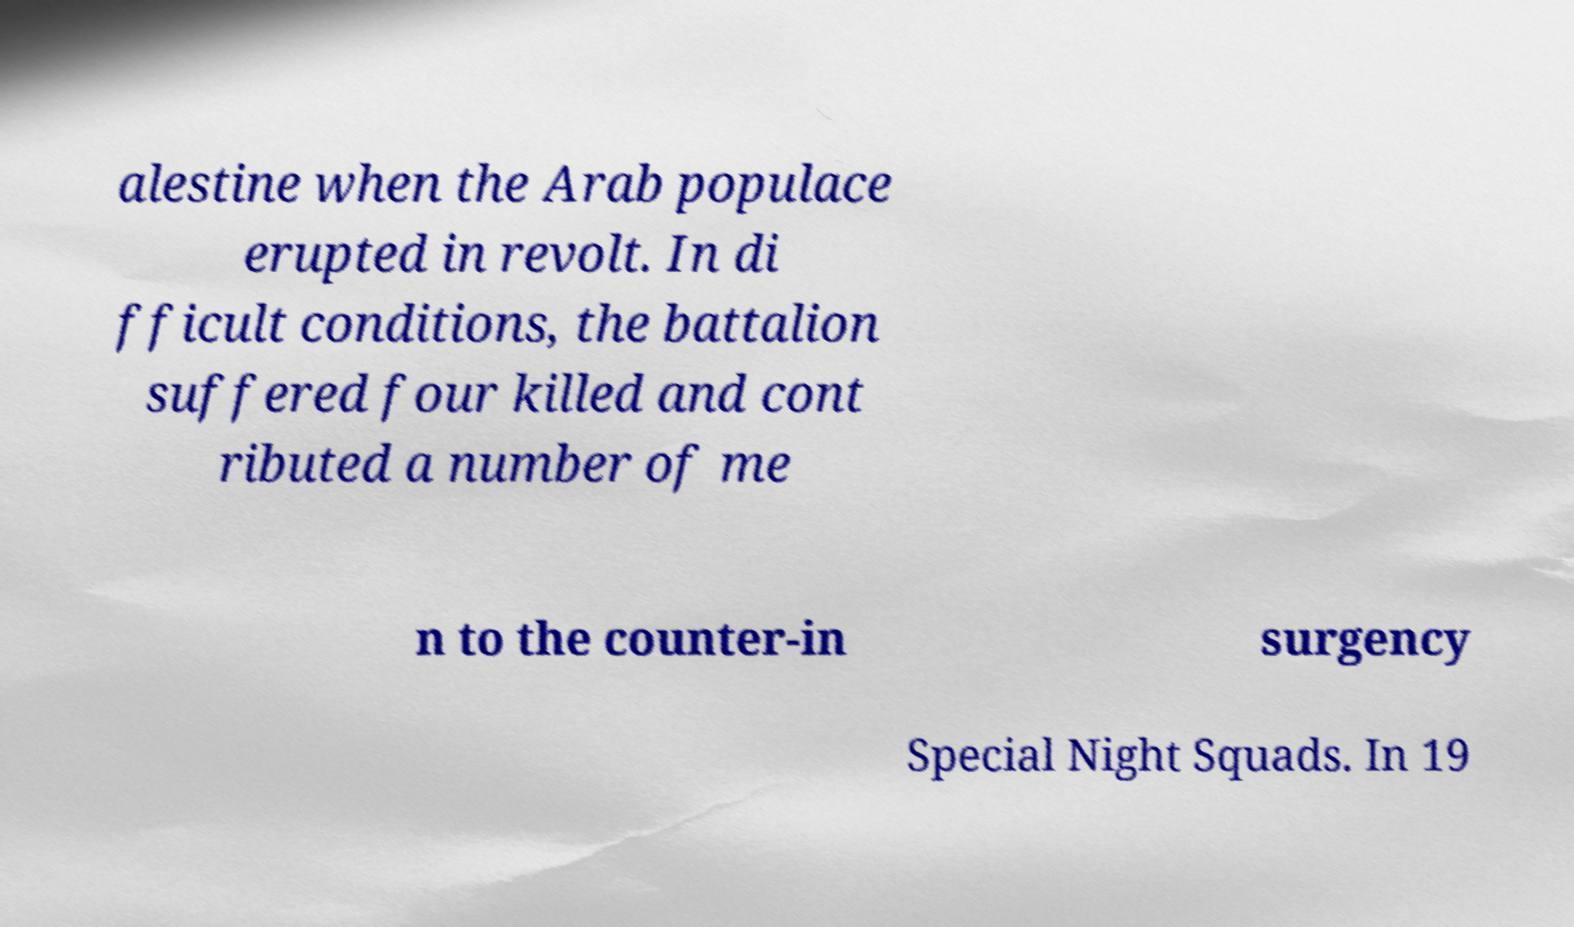For documentation purposes, I need the text within this image transcribed. Could you provide that? alestine when the Arab populace erupted in revolt. In di fficult conditions, the battalion suffered four killed and cont ributed a number of me n to the counter-in surgency Special Night Squads. In 19 